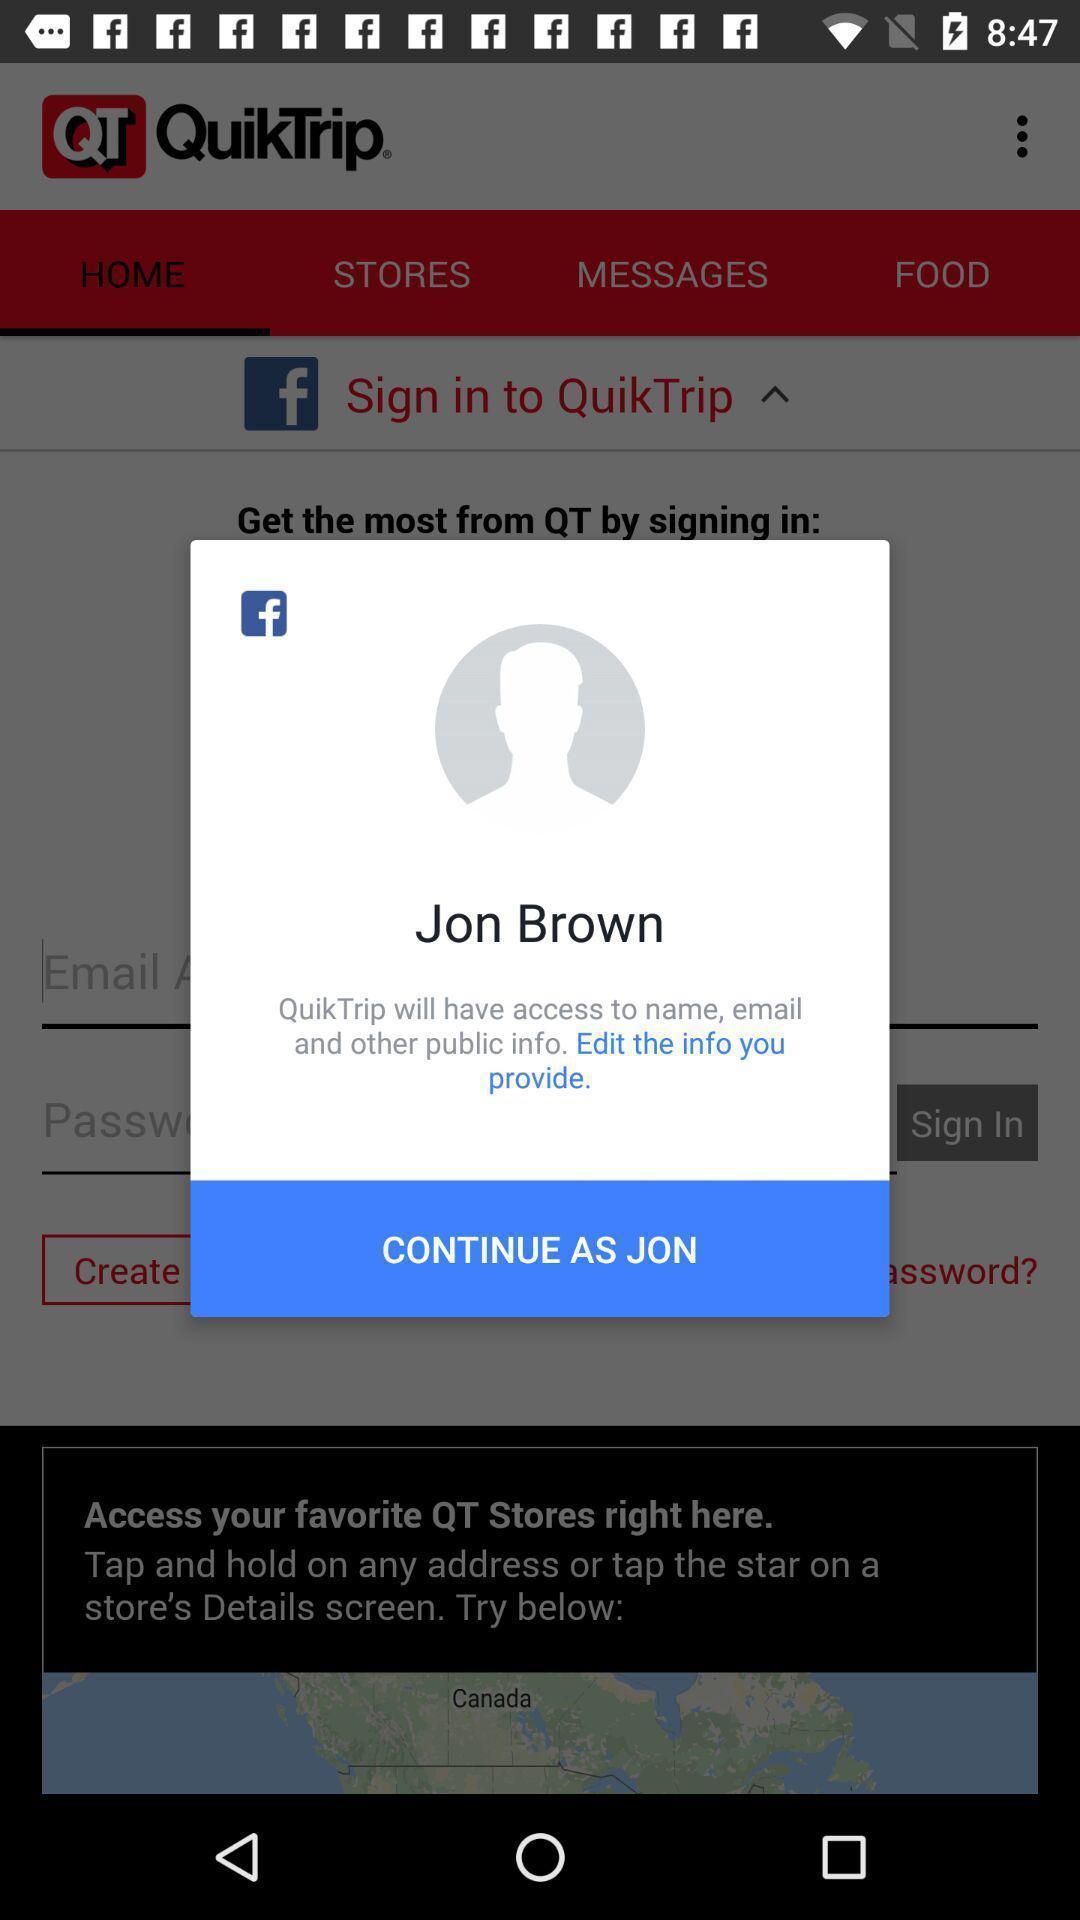What can you discern from this picture? Popup showing about profile and to continue. 